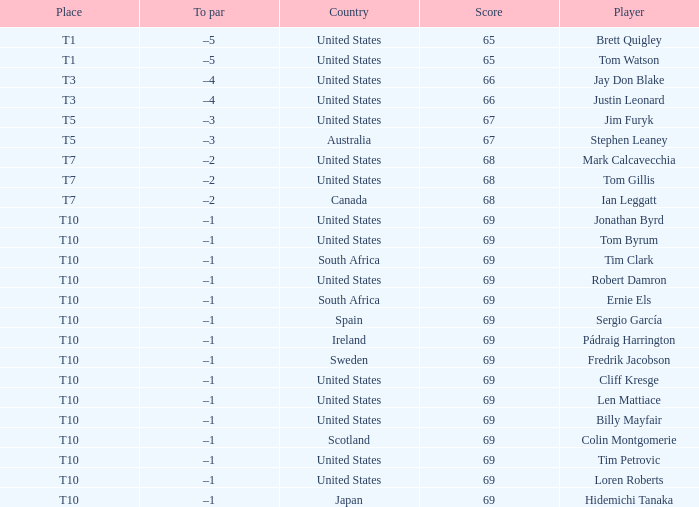What is Tom Gillis' score? 68.0. 